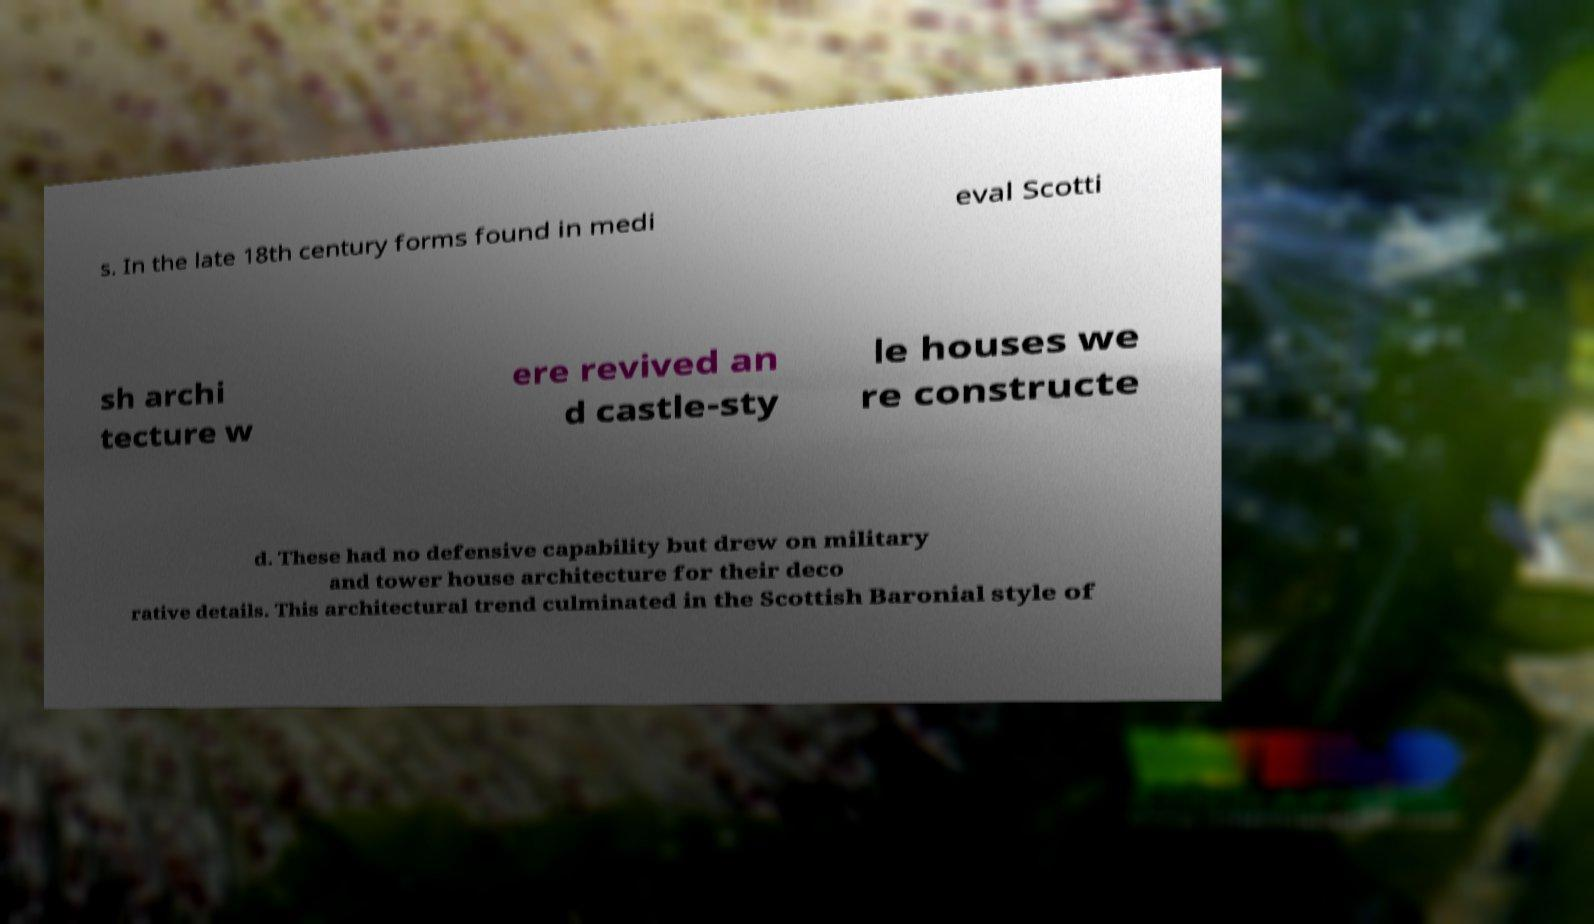Please identify and transcribe the text found in this image. s. In the late 18th century forms found in medi eval Scotti sh archi tecture w ere revived an d castle-sty le houses we re constructe d. These had no defensive capability but drew on military and tower house architecture for their deco rative details. This architectural trend culminated in the Scottish Baronial style of 